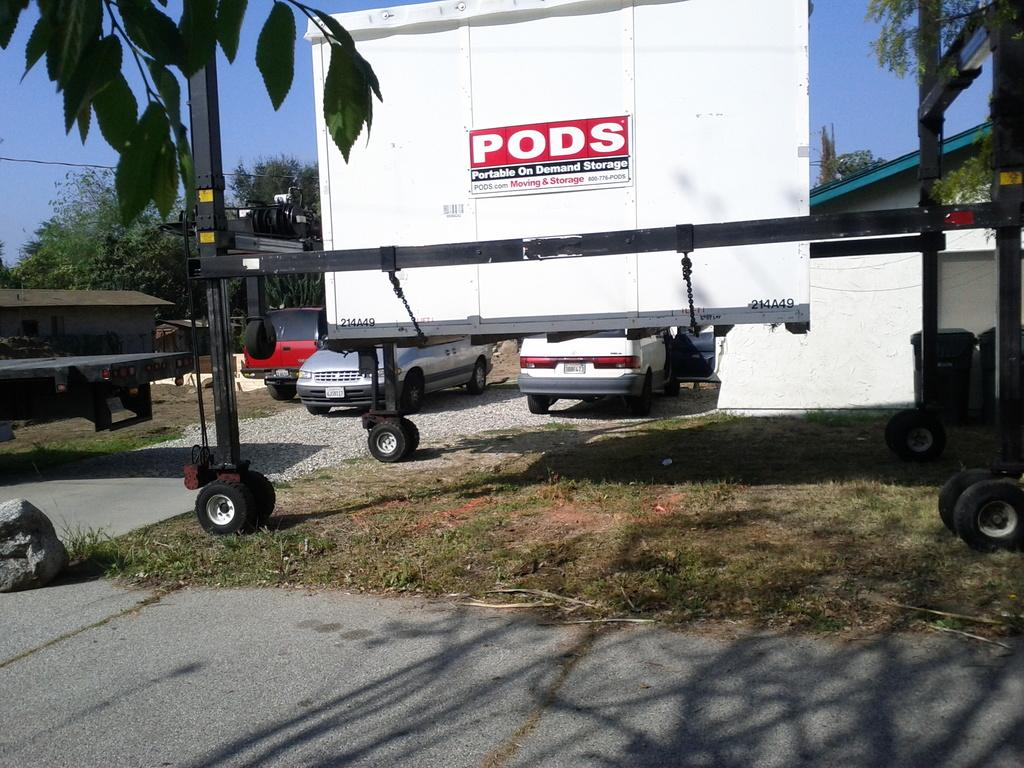What is the main subject of the image? The main subject of the image is a moving container on the grassy land. What other vehicles can be seen in the image? There are cars visible in the image. What type of natural elements are present in the image? There are trees in the image. What type of structure is present in the image? There is a house in the image. What is the color of the sky in the image? The sky is blue in the image. What is at the bottom of the image? There is a road at the bottom of the image. What type of lock is used to secure the poison in the tree in the image? There is no lock, poison, or tree present in the image. 